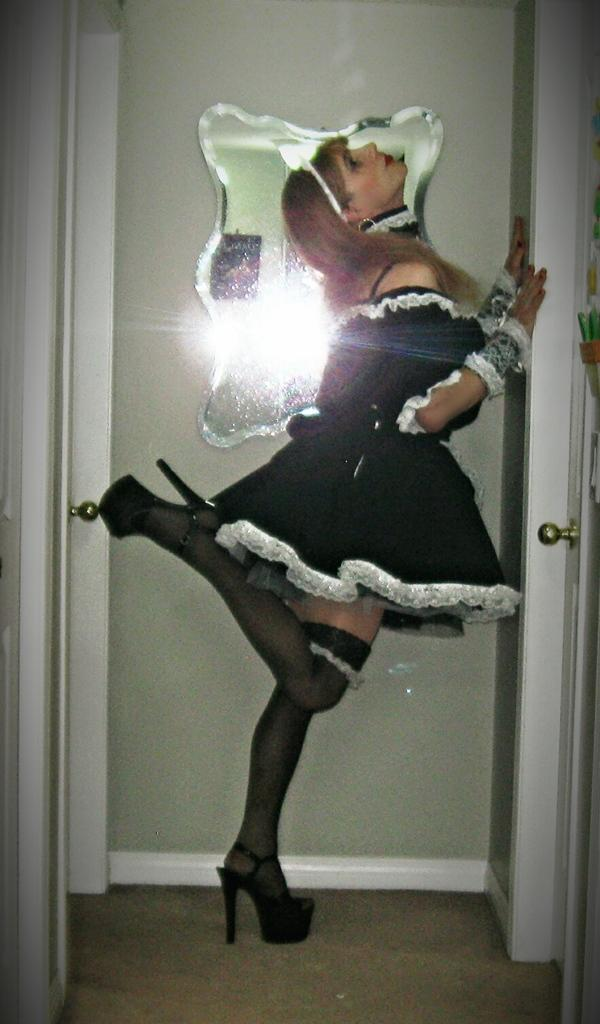What is the main subject of the image? The main subject of the image is a lady. What is the lady wearing in the image? The lady is wearing a black dress and heels. How is the lady standing in the image? The lady is standing with one leg in the image. What can be seen in the background of the image? There is a floor, a door, and a mirror associated with the door in the background of the image. How many eggs are visible in the mirror in the image? There are no eggs visible in the mirror or anywhere else in the image. What type of knowledge is the lady acquiring from the mirror in the image? The image does not suggest that the lady is acquiring any knowledge from the mirror. 